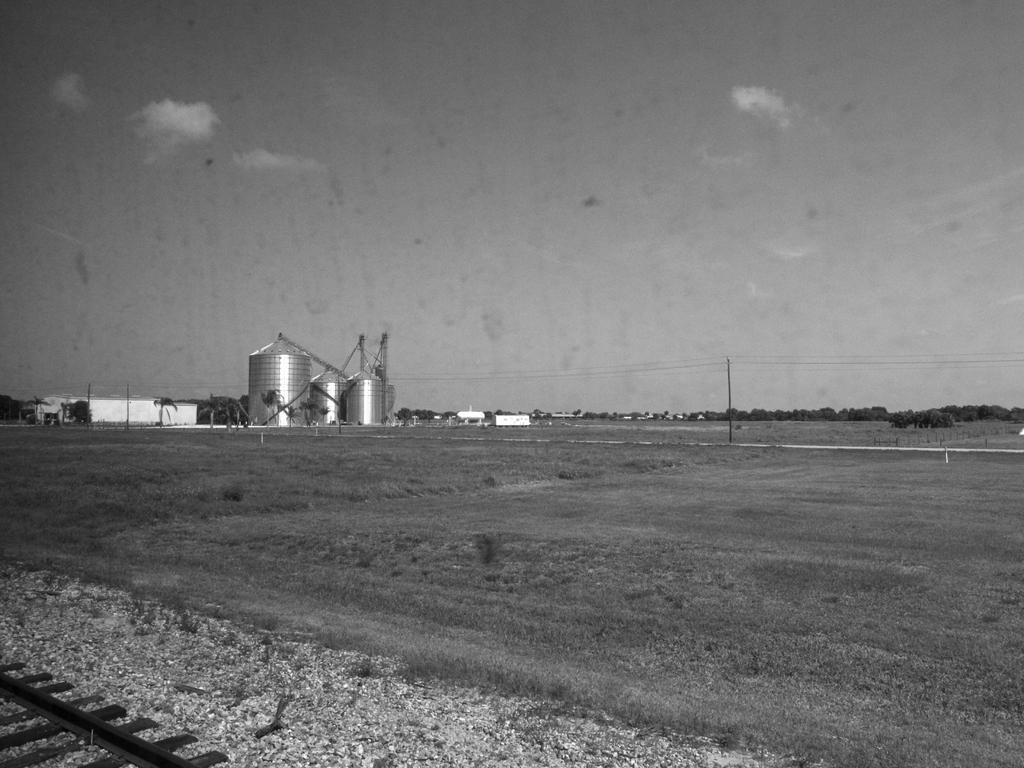What type of vegetation is present on the ground in the image? There is grass on the ground in the image. What type of transportation infrastructure is visible in the image? There is a railway track at the left side bottom corner of the image. What part of the natural environment is visible in the image? The sky is visible at the top of the image. What is the selection process for the birth of the new railway track in the image? There is no indication of a selection process or birth of a railway track in the image; it simply shows an existing railway track. Can you tell me how many deaths occurred during the construction of the railway track in the image? There is no information about the construction process or any deaths during the construction in the image. 